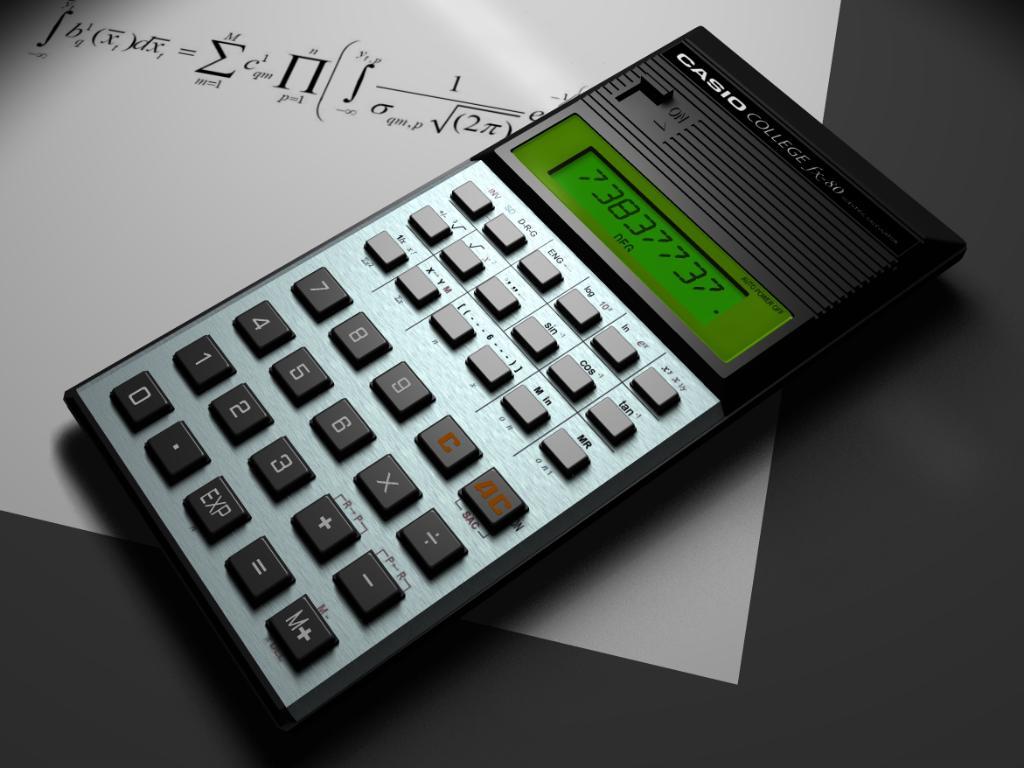What is one number button on the calculator?
Offer a very short reply. 1. 